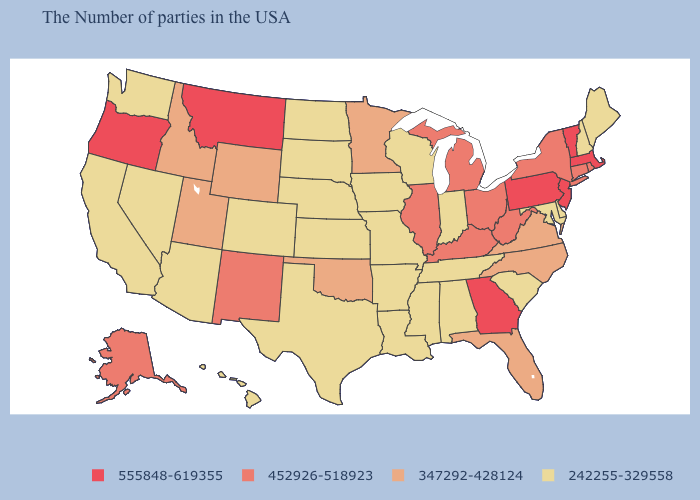Name the states that have a value in the range 242255-329558?
Concise answer only. Maine, New Hampshire, Delaware, Maryland, South Carolina, Indiana, Alabama, Tennessee, Wisconsin, Mississippi, Louisiana, Missouri, Arkansas, Iowa, Kansas, Nebraska, Texas, South Dakota, North Dakota, Colorado, Arizona, Nevada, California, Washington, Hawaii. Does Georgia have a higher value than Ohio?
Quick response, please. Yes. Name the states that have a value in the range 452926-518923?
Short answer required. Rhode Island, Connecticut, New York, West Virginia, Ohio, Michigan, Kentucky, Illinois, New Mexico, Alaska. What is the value of Virginia?
Short answer required. 347292-428124. Does Wisconsin have a lower value than South Dakota?
Give a very brief answer. No. Name the states that have a value in the range 347292-428124?
Quick response, please. Virginia, North Carolina, Florida, Minnesota, Oklahoma, Wyoming, Utah, Idaho. What is the lowest value in states that border Washington?
Concise answer only. 347292-428124. Does Kentucky have a higher value than Rhode Island?
Keep it brief. No. What is the value of Oregon?
Answer briefly. 555848-619355. Which states have the lowest value in the MidWest?
Be succinct. Indiana, Wisconsin, Missouri, Iowa, Kansas, Nebraska, South Dakota, North Dakota. What is the lowest value in the MidWest?
Give a very brief answer. 242255-329558. How many symbols are there in the legend?
Write a very short answer. 4. Which states have the lowest value in the USA?
Short answer required. Maine, New Hampshire, Delaware, Maryland, South Carolina, Indiana, Alabama, Tennessee, Wisconsin, Mississippi, Louisiana, Missouri, Arkansas, Iowa, Kansas, Nebraska, Texas, South Dakota, North Dakota, Colorado, Arizona, Nevada, California, Washington, Hawaii. Name the states that have a value in the range 555848-619355?
Answer briefly. Massachusetts, Vermont, New Jersey, Pennsylvania, Georgia, Montana, Oregon. Name the states that have a value in the range 242255-329558?
Quick response, please. Maine, New Hampshire, Delaware, Maryland, South Carolina, Indiana, Alabama, Tennessee, Wisconsin, Mississippi, Louisiana, Missouri, Arkansas, Iowa, Kansas, Nebraska, Texas, South Dakota, North Dakota, Colorado, Arizona, Nevada, California, Washington, Hawaii. 